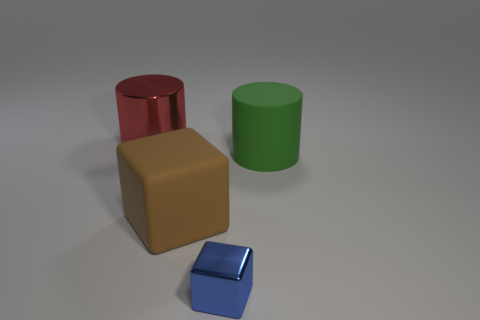Add 1 small gray rubber cylinders. How many objects exist? 5 Subtract all large purple shiny spheres. Subtract all large green matte cylinders. How many objects are left? 3 Add 4 metal blocks. How many metal blocks are left? 5 Add 1 large red cubes. How many large red cubes exist? 1 Subtract 1 blue cubes. How many objects are left? 3 